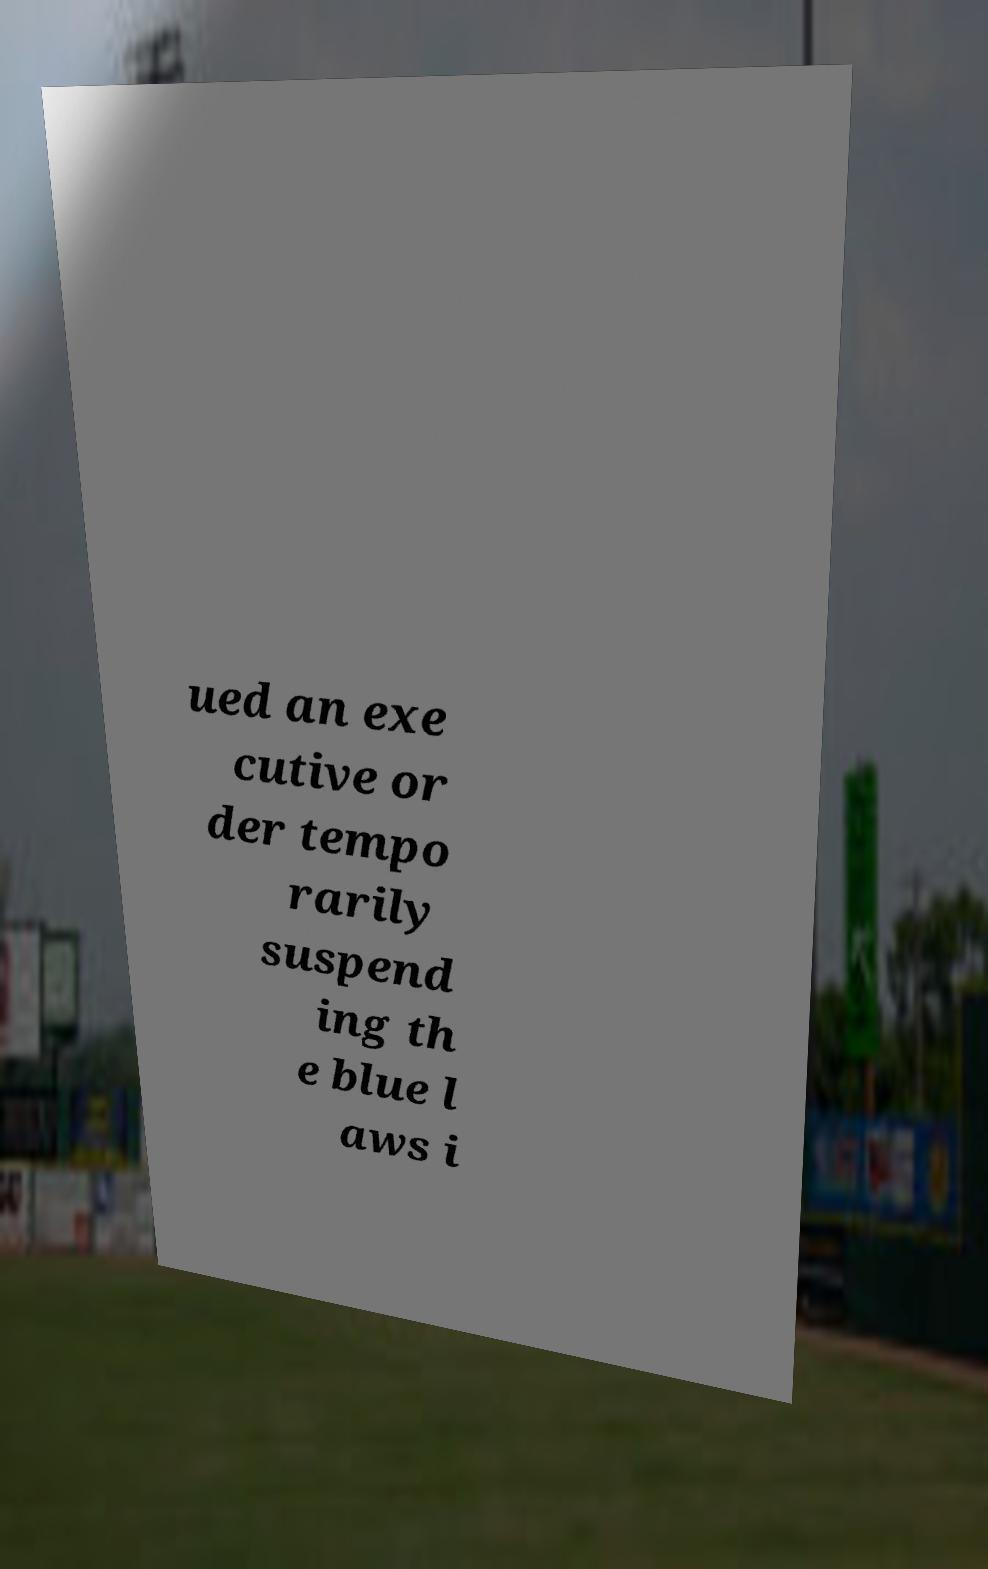Can you accurately transcribe the text from the provided image for me? ued an exe cutive or der tempo rarily suspend ing th e blue l aws i 